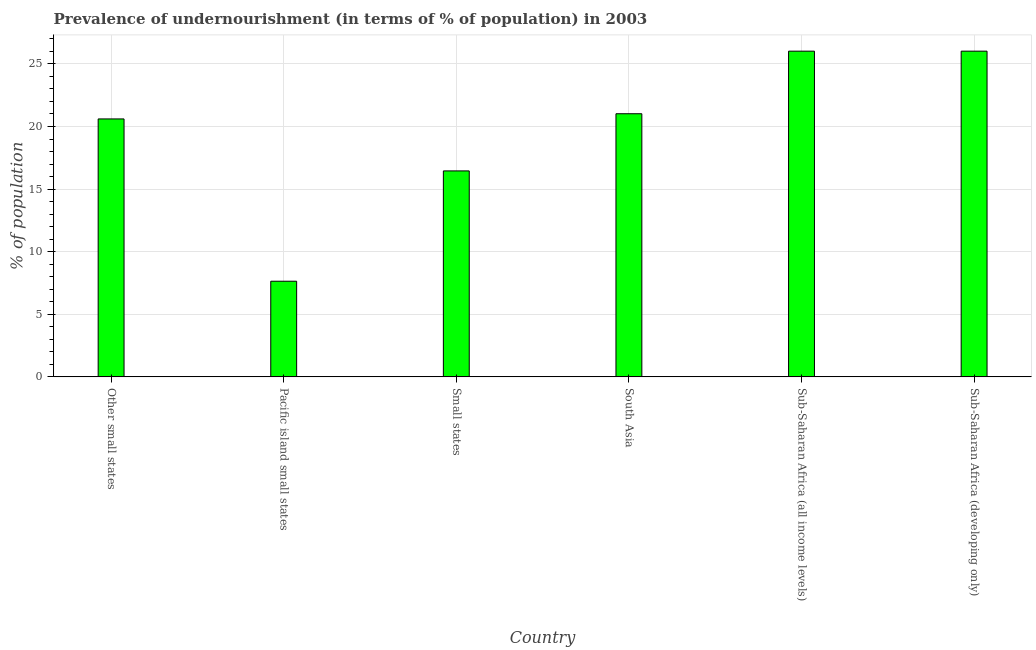Does the graph contain any zero values?
Keep it short and to the point. No. Does the graph contain grids?
Offer a terse response. Yes. What is the title of the graph?
Provide a succinct answer. Prevalence of undernourishment (in terms of % of population) in 2003. What is the label or title of the X-axis?
Offer a very short reply. Country. What is the label or title of the Y-axis?
Provide a short and direct response. % of population. What is the percentage of undernourished population in Small states?
Your answer should be very brief. 16.45. Across all countries, what is the maximum percentage of undernourished population?
Provide a short and direct response. 26.02. Across all countries, what is the minimum percentage of undernourished population?
Your answer should be compact. 7.64. In which country was the percentage of undernourished population maximum?
Offer a terse response. Sub-Saharan Africa (all income levels). In which country was the percentage of undernourished population minimum?
Your response must be concise. Pacific island small states. What is the sum of the percentage of undernourished population?
Give a very brief answer. 117.75. What is the difference between the percentage of undernourished population in South Asia and Sub-Saharan Africa (developing only)?
Keep it short and to the point. -5. What is the average percentage of undernourished population per country?
Offer a very short reply. 19.62. What is the median percentage of undernourished population?
Your answer should be very brief. 20.81. What is the ratio of the percentage of undernourished population in Pacific island small states to that in South Asia?
Offer a very short reply. 0.36. Is the sum of the percentage of undernourished population in Small states and South Asia greater than the maximum percentage of undernourished population across all countries?
Provide a succinct answer. Yes. What is the difference between the highest and the lowest percentage of undernourished population?
Give a very brief answer. 18.38. How many bars are there?
Provide a succinct answer. 6. Are all the bars in the graph horizontal?
Your answer should be compact. No. How many countries are there in the graph?
Ensure brevity in your answer.  6. What is the % of population in Other small states?
Offer a very short reply. 20.6. What is the % of population of Pacific island small states?
Ensure brevity in your answer.  7.64. What is the % of population in Small states?
Give a very brief answer. 16.45. What is the % of population of South Asia?
Offer a terse response. 21.02. What is the % of population of Sub-Saharan Africa (all income levels)?
Ensure brevity in your answer.  26.02. What is the % of population in Sub-Saharan Africa (developing only)?
Offer a terse response. 26.02. What is the difference between the % of population in Other small states and Pacific island small states?
Ensure brevity in your answer.  12.96. What is the difference between the % of population in Other small states and Small states?
Provide a short and direct response. 4.15. What is the difference between the % of population in Other small states and South Asia?
Offer a very short reply. -0.41. What is the difference between the % of population in Other small states and Sub-Saharan Africa (all income levels)?
Give a very brief answer. -5.41. What is the difference between the % of population in Other small states and Sub-Saharan Africa (developing only)?
Your answer should be compact. -5.41. What is the difference between the % of population in Pacific island small states and Small states?
Ensure brevity in your answer.  -8.81. What is the difference between the % of population in Pacific island small states and South Asia?
Ensure brevity in your answer.  -13.38. What is the difference between the % of population in Pacific island small states and Sub-Saharan Africa (all income levels)?
Your response must be concise. -18.38. What is the difference between the % of population in Pacific island small states and Sub-Saharan Africa (developing only)?
Make the answer very short. -18.38. What is the difference between the % of population in Small states and South Asia?
Your response must be concise. -4.57. What is the difference between the % of population in Small states and Sub-Saharan Africa (all income levels)?
Provide a short and direct response. -9.57. What is the difference between the % of population in Small states and Sub-Saharan Africa (developing only)?
Your answer should be compact. -9.57. What is the difference between the % of population in South Asia and Sub-Saharan Africa (all income levels)?
Your answer should be very brief. -5. What is the difference between the % of population in South Asia and Sub-Saharan Africa (developing only)?
Provide a short and direct response. -5. What is the difference between the % of population in Sub-Saharan Africa (all income levels) and Sub-Saharan Africa (developing only)?
Give a very brief answer. 0. What is the ratio of the % of population in Other small states to that in Pacific island small states?
Ensure brevity in your answer.  2.7. What is the ratio of the % of population in Other small states to that in Small states?
Ensure brevity in your answer.  1.25. What is the ratio of the % of population in Other small states to that in South Asia?
Your response must be concise. 0.98. What is the ratio of the % of population in Other small states to that in Sub-Saharan Africa (all income levels)?
Provide a succinct answer. 0.79. What is the ratio of the % of population in Other small states to that in Sub-Saharan Africa (developing only)?
Your answer should be very brief. 0.79. What is the ratio of the % of population in Pacific island small states to that in Small states?
Keep it short and to the point. 0.46. What is the ratio of the % of population in Pacific island small states to that in South Asia?
Your answer should be very brief. 0.36. What is the ratio of the % of population in Pacific island small states to that in Sub-Saharan Africa (all income levels)?
Your response must be concise. 0.29. What is the ratio of the % of population in Pacific island small states to that in Sub-Saharan Africa (developing only)?
Ensure brevity in your answer.  0.29. What is the ratio of the % of population in Small states to that in South Asia?
Provide a short and direct response. 0.78. What is the ratio of the % of population in Small states to that in Sub-Saharan Africa (all income levels)?
Your answer should be compact. 0.63. What is the ratio of the % of population in Small states to that in Sub-Saharan Africa (developing only)?
Offer a very short reply. 0.63. What is the ratio of the % of population in South Asia to that in Sub-Saharan Africa (all income levels)?
Ensure brevity in your answer.  0.81. What is the ratio of the % of population in South Asia to that in Sub-Saharan Africa (developing only)?
Make the answer very short. 0.81. What is the ratio of the % of population in Sub-Saharan Africa (all income levels) to that in Sub-Saharan Africa (developing only)?
Offer a terse response. 1. 